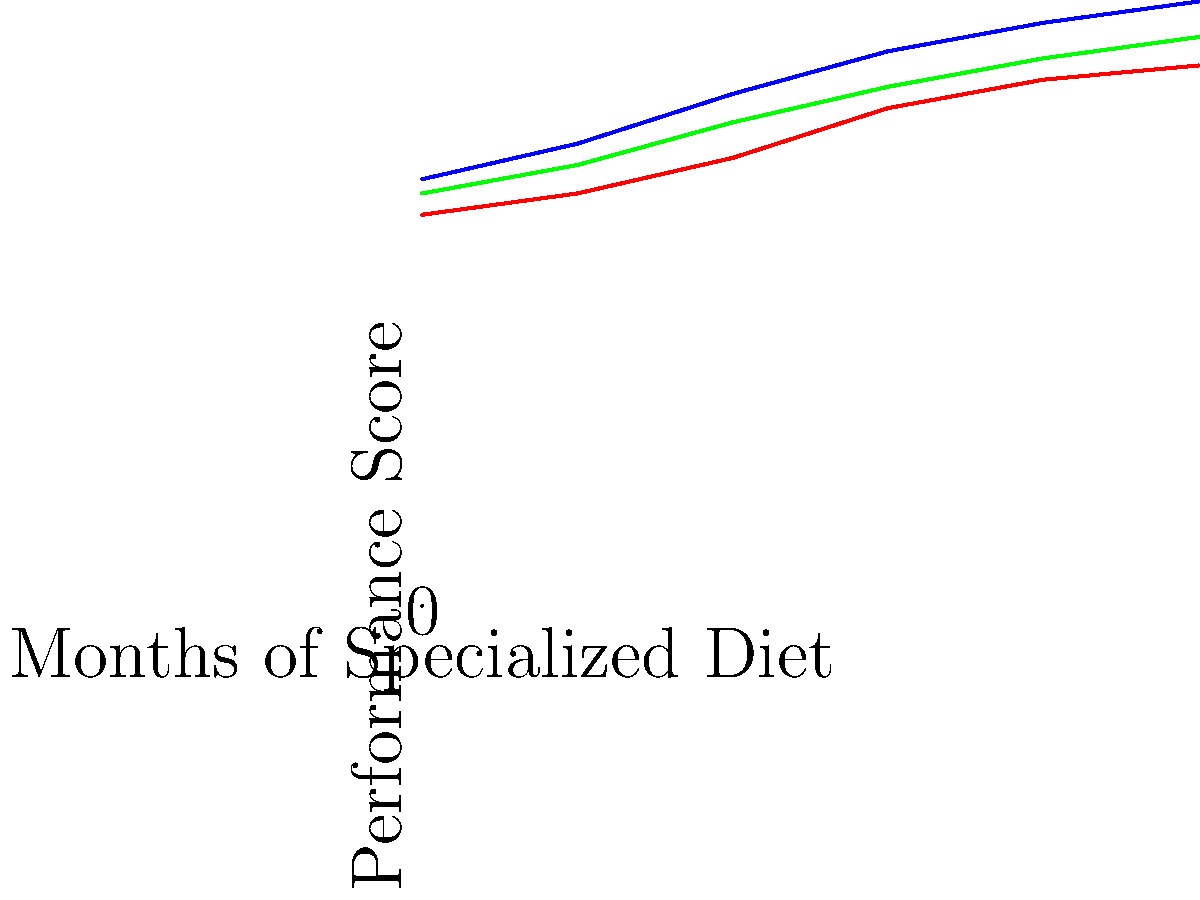Based on the line graph showing the correlation between a horse's diet and its performance in equestrian events over a 5-month period, which diet resulted in the highest performance score at the end of the study, and by how many points did it outperform the standard diet? To answer this question, we need to follow these steps:

1. Identify the three diets represented in the graph:
   - Blue line: High-protein diet
   - Red line: Standard diet
   - Green line: Balanced diet

2. Locate the final performance scores at the 5-month mark:
   - High-protein diet: 85 points
   - Standard diet: 76 points
   - Balanced diet: 80 points

3. Determine which diet had the highest score:
   The high-protein diet (blue line) shows the highest performance score of 85 points at the end of the 5-month period.

4. Calculate the difference between the highest-performing diet and the standard diet:
   $85 - 76 = 9$ points

Therefore, the high-protein diet resulted in the highest performance score and outperformed the standard diet by 9 points at the end of the study.
Answer: High-protein diet, 9 points 